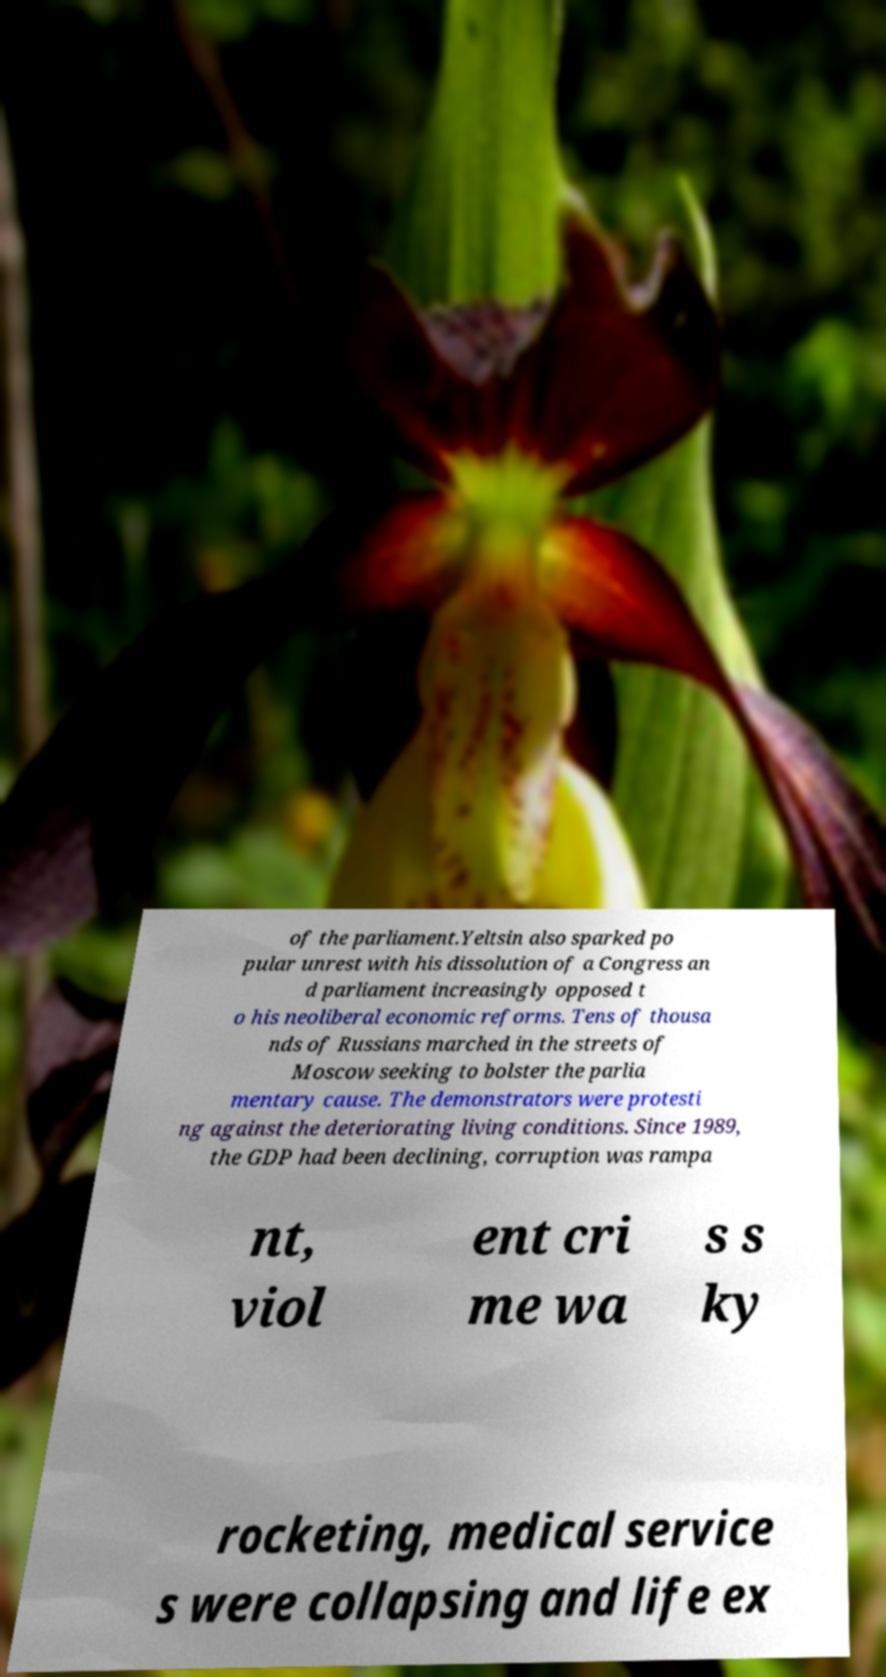Could you assist in decoding the text presented in this image and type it out clearly? of the parliament.Yeltsin also sparked po pular unrest with his dissolution of a Congress an d parliament increasingly opposed t o his neoliberal economic reforms. Tens of thousa nds of Russians marched in the streets of Moscow seeking to bolster the parlia mentary cause. The demonstrators were protesti ng against the deteriorating living conditions. Since 1989, the GDP had been declining, corruption was rampa nt, viol ent cri me wa s s ky rocketing, medical service s were collapsing and life ex 